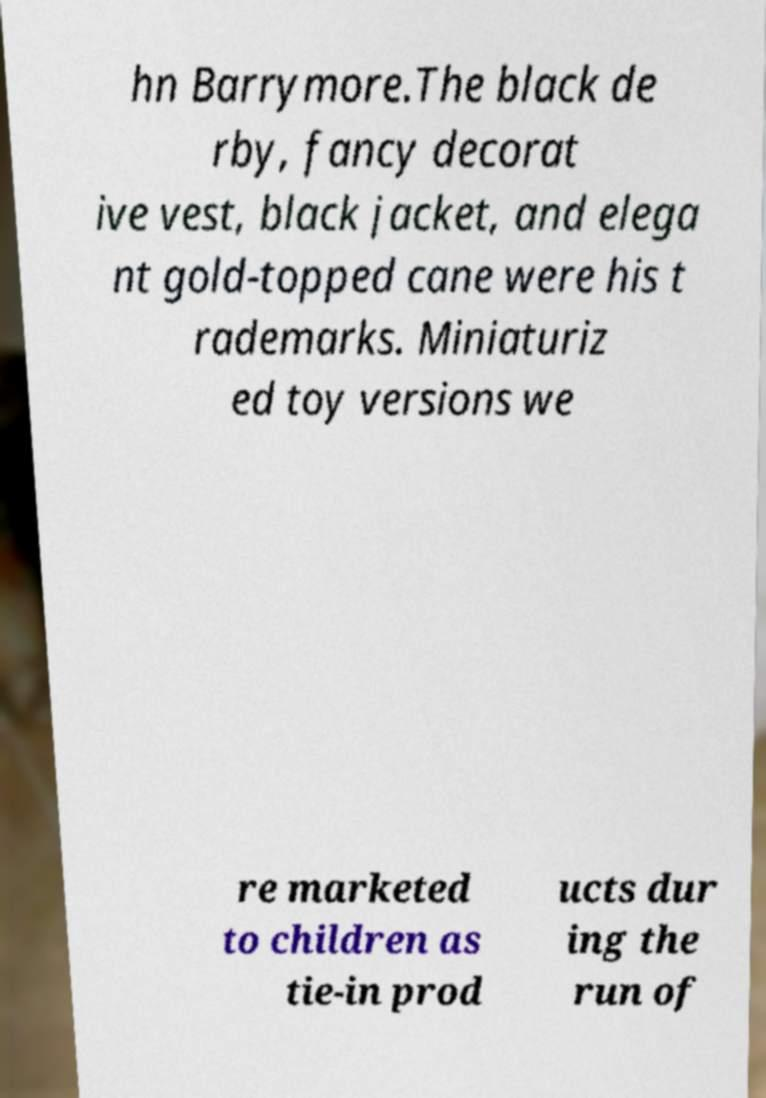I need the written content from this picture converted into text. Can you do that? hn Barrymore.The black de rby, fancy decorat ive vest, black jacket, and elega nt gold-topped cane were his t rademarks. Miniaturiz ed toy versions we re marketed to children as tie-in prod ucts dur ing the run of 